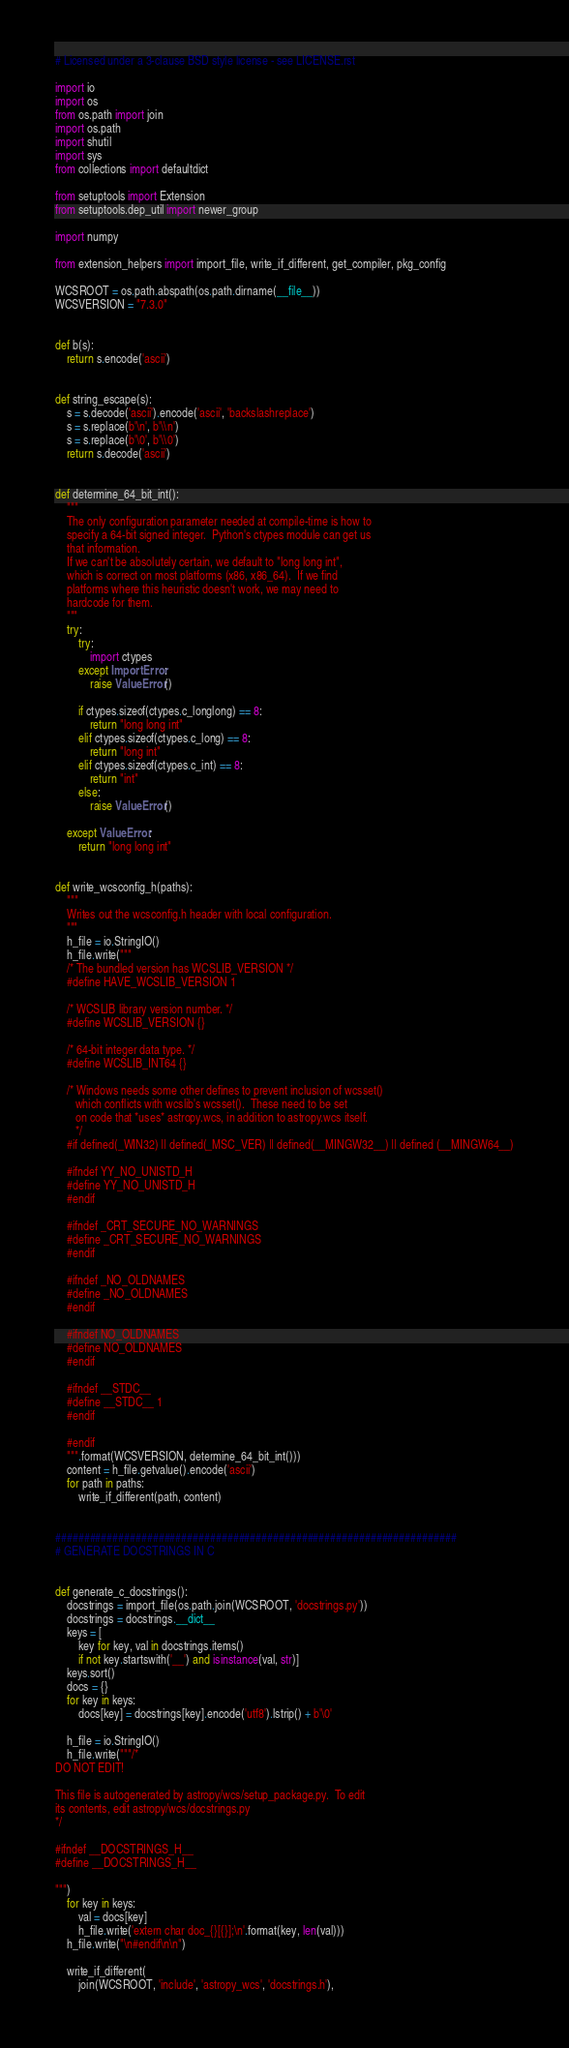Convert code to text. <code><loc_0><loc_0><loc_500><loc_500><_Python_># Licensed under a 3-clause BSD style license - see LICENSE.rst

import io
import os
from os.path import join
import os.path
import shutil
import sys
from collections import defaultdict

from setuptools import Extension
from setuptools.dep_util import newer_group

import numpy

from extension_helpers import import_file, write_if_different, get_compiler, pkg_config

WCSROOT = os.path.abspath(os.path.dirname(__file__))
WCSVERSION = "7.3.0"


def b(s):
    return s.encode('ascii')


def string_escape(s):
    s = s.decode('ascii').encode('ascii', 'backslashreplace')
    s = s.replace(b'\n', b'\\n')
    s = s.replace(b'\0', b'\\0')
    return s.decode('ascii')


def determine_64_bit_int():
    """
    The only configuration parameter needed at compile-time is how to
    specify a 64-bit signed integer.  Python's ctypes module can get us
    that information.
    If we can't be absolutely certain, we default to "long long int",
    which is correct on most platforms (x86, x86_64).  If we find
    platforms where this heuristic doesn't work, we may need to
    hardcode for them.
    """
    try:
        try:
            import ctypes
        except ImportError:
            raise ValueError()

        if ctypes.sizeof(ctypes.c_longlong) == 8:
            return "long long int"
        elif ctypes.sizeof(ctypes.c_long) == 8:
            return "long int"
        elif ctypes.sizeof(ctypes.c_int) == 8:
            return "int"
        else:
            raise ValueError()

    except ValueError:
        return "long long int"


def write_wcsconfig_h(paths):
    """
    Writes out the wcsconfig.h header with local configuration.
    """
    h_file = io.StringIO()
    h_file.write("""
    /* The bundled version has WCSLIB_VERSION */
    #define HAVE_WCSLIB_VERSION 1

    /* WCSLIB library version number. */
    #define WCSLIB_VERSION {}

    /* 64-bit integer data type. */
    #define WCSLIB_INT64 {}

    /* Windows needs some other defines to prevent inclusion of wcsset()
       which conflicts with wcslib's wcsset().  These need to be set
       on code that *uses* astropy.wcs, in addition to astropy.wcs itself.
       */
    #if defined(_WIN32) || defined(_MSC_VER) || defined(__MINGW32__) || defined (__MINGW64__)

    #ifndef YY_NO_UNISTD_H
    #define YY_NO_UNISTD_H
    #endif

    #ifndef _CRT_SECURE_NO_WARNINGS
    #define _CRT_SECURE_NO_WARNINGS
    #endif

    #ifndef _NO_OLDNAMES
    #define _NO_OLDNAMES
    #endif

    #ifndef NO_OLDNAMES
    #define NO_OLDNAMES
    #endif

    #ifndef __STDC__
    #define __STDC__ 1
    #endif

    #endif
    """.format(WCSVERSION, determine_64_bit_int()))
    content = h_file.getvalue().encode('ascii')
    for path in paths:
        write_if_different(path, content)


######################################################################
# GENERATE DOCSTRINGS IN C


def generate_c_docstrings():
    docstrings = import_file(os.path.join(WCSROOT, 'docstrings.py'))
    docstrings = docstrings.__dict__
    keys = [
        key for key, val in docstrings.items()
        if not key.startswith('__') and isinstance(val, str)]
    keys.sort()
    docs = {}
    for key in keys:
        docs[key] = docstrings[key].encode('utf8').lstrip() + b'\0'

    h_file = io.StringIO()
    h_file.write("""/*
DO NOT EDIT!

This file is autogenerated by astropy/wcs/setup_package.py.  To edit
its contents, edit astropy/wcs/docstrings.py
*/

#ifndef __DOCSTRINGS_H__
#define __DOCSTRINGS_H__

""")
    for key in keys:
        val = docs[key]
        h_file.write('extern char doc_{}[{}];\n'.format(key, len(val)))
    h_file.write("\n#endif\n\n")

    write_if_different(
        join(WCSROOT, 'include', 'astropy_wcs', 'docstrings.h'),</code> 